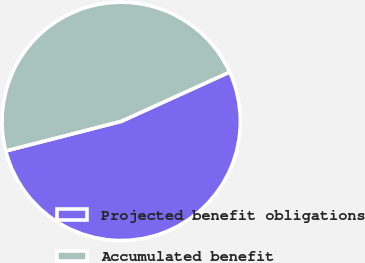Convert chart. <chart><loc_0><loc_0><loc_500><loc_500><pie_chart><fcel>Projected benefit obligations<fcel>Accumulated benefit<nl><fcel>52.8%<fcel>47.2%<nl></chart> 